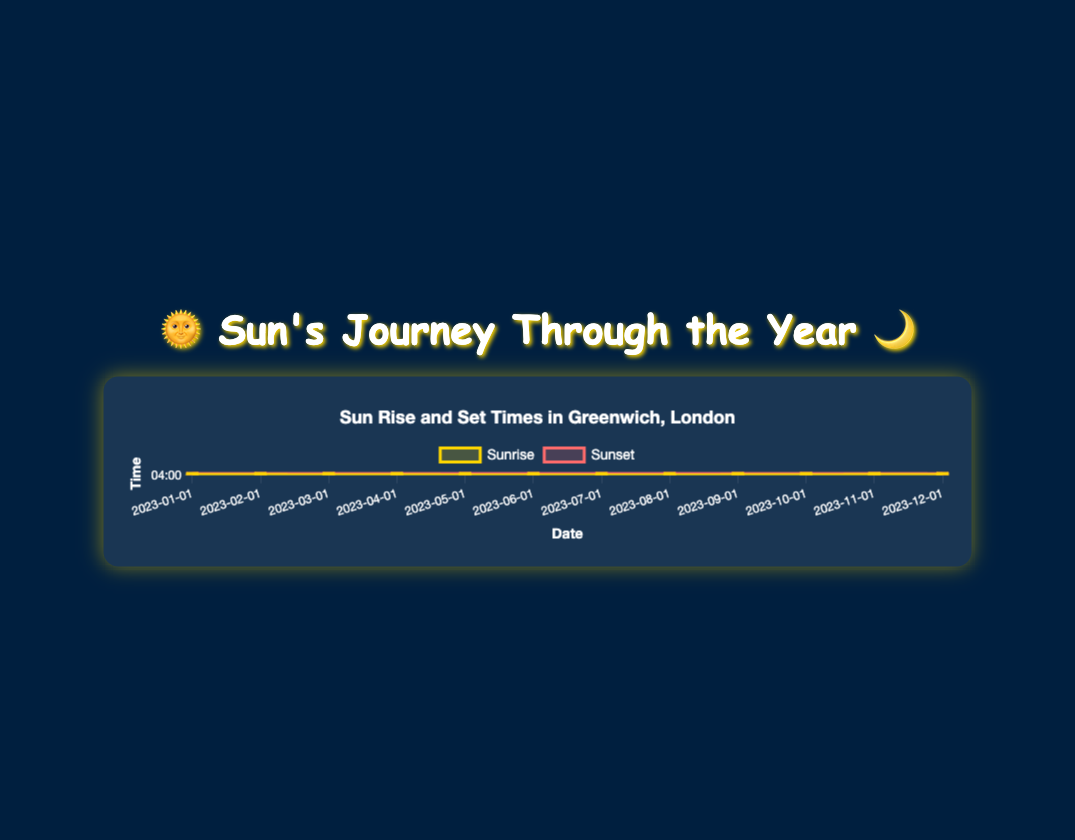When is the earliest sunset in the year? Looking at the "Sunset" line on the chart, the lowest point occurs on 2023-12-01, which is at 15:55.
Answer: 2023-12-01 Does sunrise get earlier or later from January to June? By observing the "Sunrise" line from January to June, we see that it gets earlier from January until June. January starts at 08:06 and goes down to 04:50 in June.
Answer: Earlier Which month has the longest daylight duration? To find the month with the longest daylight, look for the largest gap between the sunrise and sunset lines. In June, the sunset is at 21:03 and sunrise at 04:50, resulting in the longest daylight duration.
Answer: June What is the difference in sunrise times between March and October? Sunrise on 2023-03-01 is at 06:49, and on 2023-10-01 it's at 06:55. The difference is 6 minutes.
Answer: 6 minutes Which month has the earliest sunrise? Looking at the "Sunrise" line, the earliest sunrise is at 04:45 in July.
Answer: July Is the sunset time in December earlier or later than in January? Comparing the sunset times, December (15:55) is earlier than January (16:01).
Answer: Earlier What is the average sunset time in June and July? Convert the sunset times for June (21:03) and July (21:21) to decimal hours: 21.05 and 21.35. The average is (21.05 + 21.35)/2 = 21.2, which is 21:12.
Answer: 21:12 How much earlier is the sunset in October compared to August? Sunset in October (18:34) and in August (21:01). Converting to decimal, October is 18.57; August is 21.02. The difference is 21.02 - 18.57 = 2.45 hours, or 2 hours 27 minutes.
Answer: 2 hours 27 minutes 